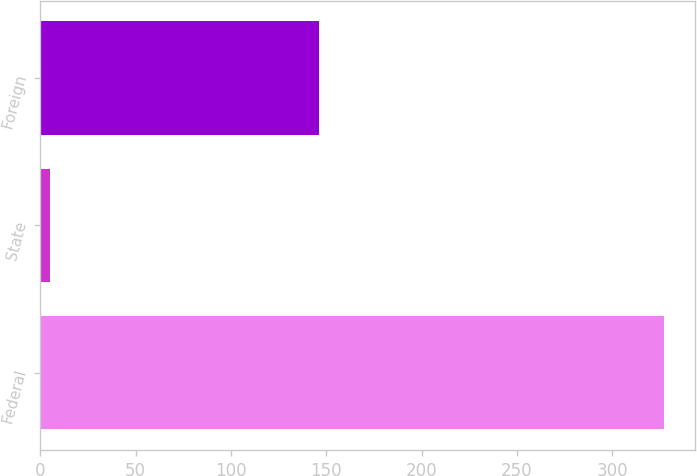Convert chart to OTSL. <chart><loc_0><loc_0><loc_500><loc_500><bar_chart><fcel>Federal<fcel>State<fcel>Foreign<nl><fcel>327<fcel>5<fcel>146<nl></chart> 